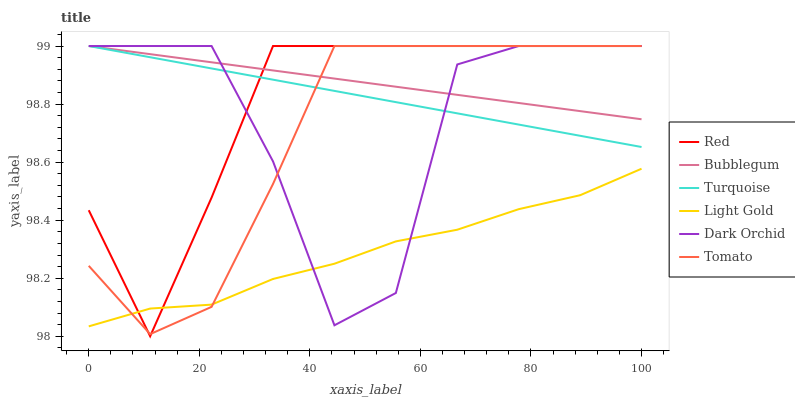Does Light Gold have the minimum area under the curve?
Answer yes or no. Yes. Does Bubblegum have the maximum area under the curve?
Answer yes or no. Yes. Does Turquoise have the minimum area under the curve?
Answer yes or no. No. Does Turquoise have the maximum area under the curve?
Answer yes or no. No. Is Bubblegum the smoothest?
Answer yes or no. Yes. Is Dark Orchid the roughest?
Answer yes or no. Yes. Is Turquoise the smoothest?
Answer yes or no. No. Is Turquoise the roughest?
Answer yes or no. No. Does Red have the lowest value?
Answer yes or no. Yes. Does Turquoise have the lowest value?
Answer yes or no. No. Does Red have the highest value?
Answer yes or no. Yes. Does Light Gold have the highest value?
Answer yes or no. No. Is Light Gold less than Bubblegum?
Answer yes or no. Yes. Is Turquoise greater than Light Gold?
Answer yes or no. Yes. Does Tomato intersect Turquoise?
Answer yes or no. Yes. Is Tomato less than Turquoise?
Answer yes or no. No. Is Tomato greater than Turquoise?
Answer yes or no. No. Does Light Gold intersect Bubblegum?
Answer yes or no. No. 